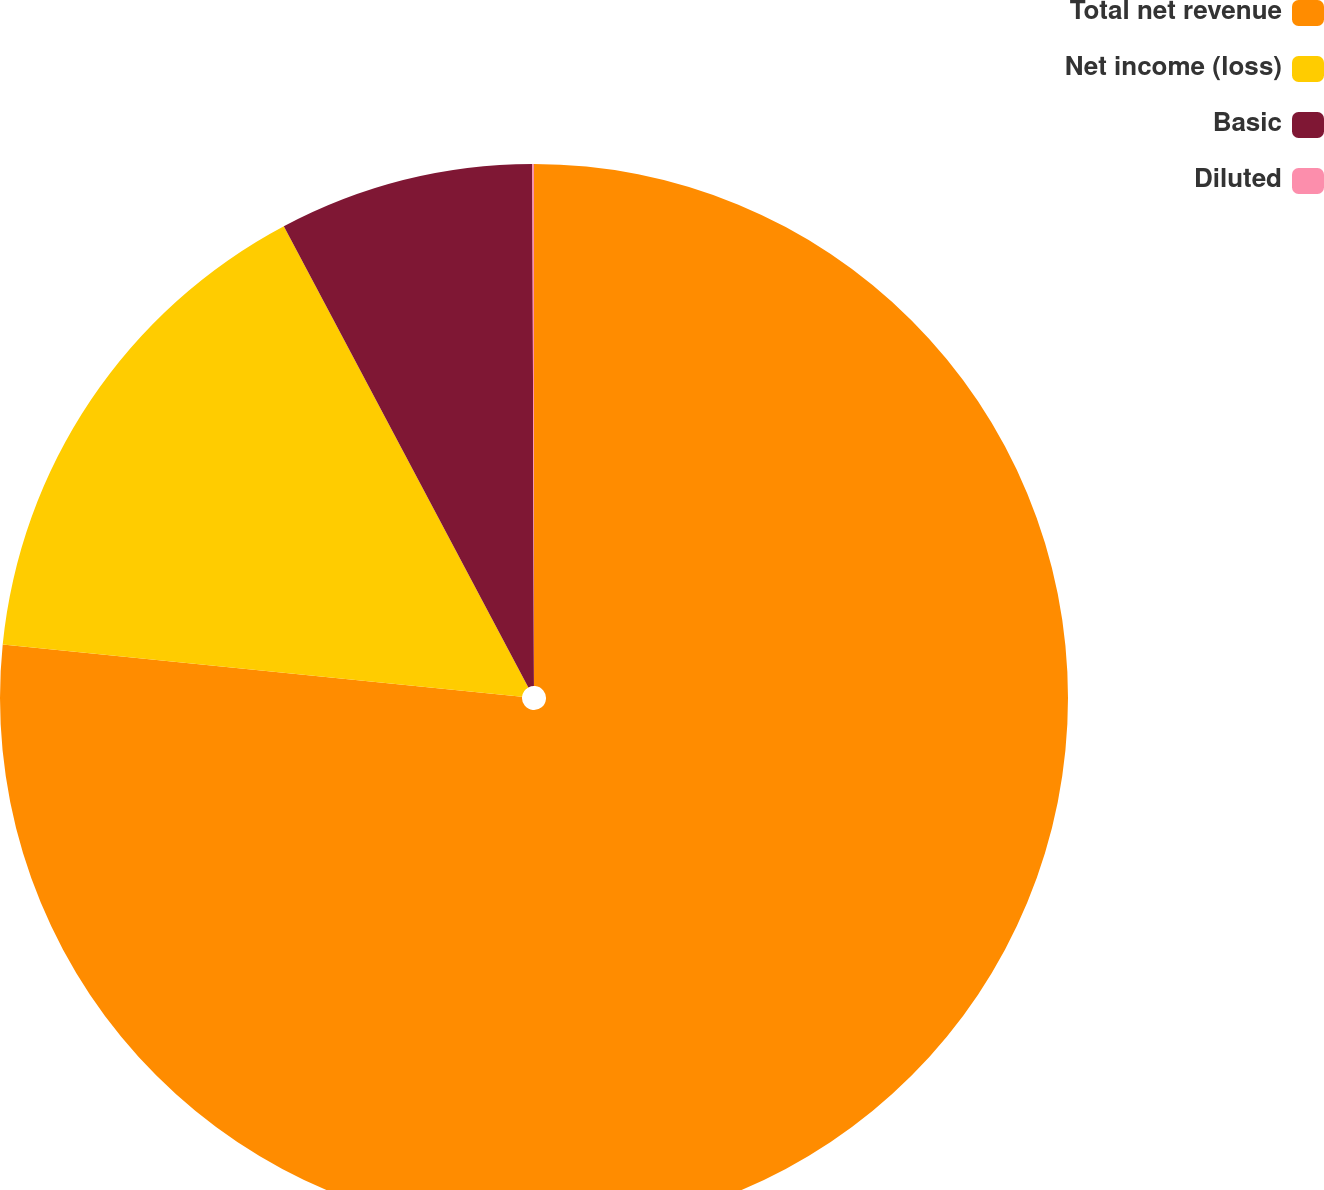Convert chart. <chart><loc_0><loc_0><loc_500><loc_500><pie_chart><fcel>Total net revenue<fcel>Net income (loss)<fcel>Basic<fcel>Diluted<nl><fcel>76.6%<fcel>15.64%<fcel>7.71%<fcel>0.05%<nl></chart> 